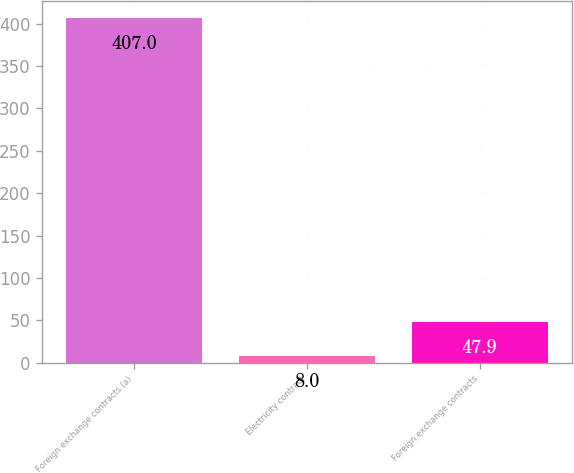Convert chart. <chart><loc_0><loc_0><loc_500><loc_500><bar_chart><fcel>Foreign exchange contracts (a)<fcel>Electricity contract<fcel>Foreign exchange contracts<nl><fcel>407<fcel>8<fcel>47.9<nl></chart> 